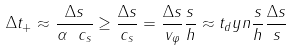<formula> <loc_0><loc_0><loc_500><loc_500>\Delta t _ { + } \approx \frac { \Delta s } { \alpha \ c _ { s } } \geq \frac { \Delta s } { c _ { s } } = \frac { \Delta s } { v _ { \varphi } } \frac { s } { h } \approx t _ { d } y n \frac { s } { h } \frac { \Delta s } { s }</formula> 